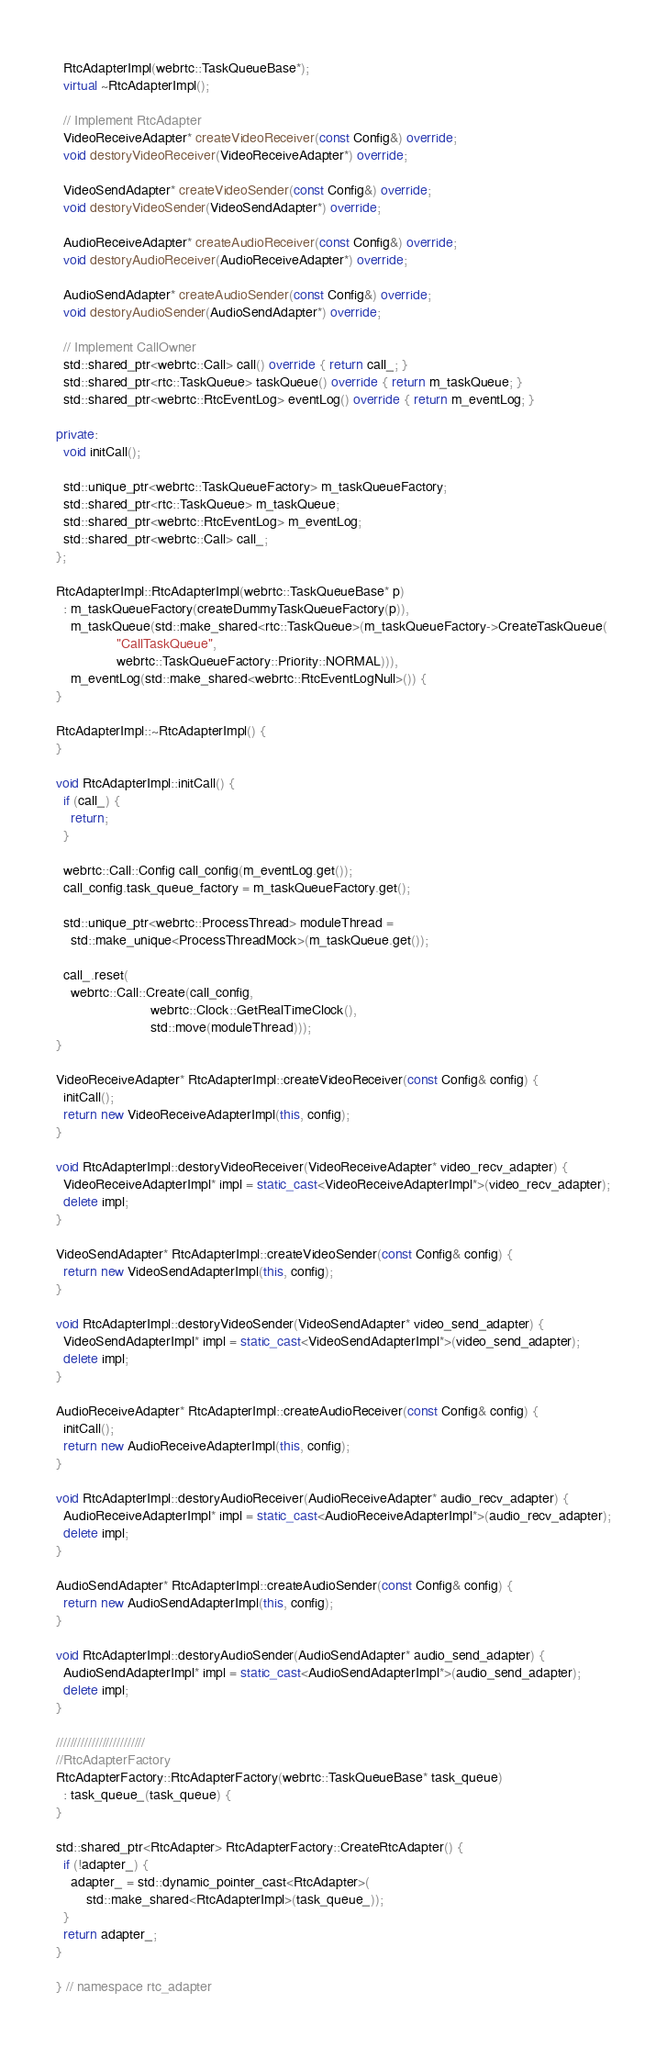Convert code to text. <code><loc_0><loc_0><loc_500><loc_500><_C++_>  RtcAdapterImpl(webrtc::TaskQueueBase*);
  virtual ~RtcAdapterImpl();

  // Implement RtcAdapter
  VideoReceiveAdapter* createVideoReceiver(const Config&) override;
  void destoryVideoReceiver(VideoReceiveAdapter*) override;
  
  VideoSendAdapter* createVideoSender(const Config&) override;
  void destoryVideoSender(VideoSendAdapter*) override;
  
  AudioReceiveAdapter* createAudioReceiver(const Config&) override;
  void destoryAudioReceiver(AudioReceiveAdapter*) override;
  
  AudioSendAdapter* createAudioSender(const Config&) override;
  void destoryAudioSender(AudioSendAdapter*) override;

  // Implement CallOwner
  std::shared_ptr<webrtc::Call> call() override { return call_; }
  std::shared_ptr<rtc::TaskQueue> taskQueue() override { return m_taskQueue; }
  std::shared_ptr<webrtc::RtcEventLog> eventLog() override { return m_eventLog; }

private:
  void initCall();

  std::unique_ptr<webrtc::TaskQueueFactory> m_taskQueueFactory;
  std::shared_ptr<rtc::TaskQueue> m_taskQueue;
  std::shared_ptr<webrtc::RtcEventLog> m_eventLog;
  std::shared_ptr<webrtc::Call> call_;
};

RtcAdapterImpl::RtcAdapterImpl(webrtc::TaskQueueBase* p)
  : m_taskQueueFactory(createDummyTaskQueueFactory(p)),
    m_taskQueue(std::make_shared<rtc::TaskQueue>(m_taskQueueFactory->CreateTaskQueue(
                "CallTaskQueue",
                webrtc::TaskQueueFactory::Priority::NORMAL))),
    m_eventLog(std::make_shared<webrtc::RtcEventLogNull>()) {
}

RtcAdapterImpl::~RtcAdapterImpl() {
}

void RtcAdapterImpl::initCall() {
  if (call_) {
    return;
  }
  
  webrtc::Call::Config call_config(m_eventLog.get());
  call_config.task_queue_factory = m_taskQueueFactory.get();

  std::unique_ptr<webrtc::ProcessThread> moduleThread =
    std::make_unique<ProcessThreadMock>(m_taskQueue.get());
    
  call_.reset(
    webrtc::Call::Create(call_config, 
                         webrtc::Clock::GetRealTimeClock(), 
                         std::move(moduleThread)));
}

VideoReceiveAdapter* RtcAdapterImpl::createVideoReceiver(const Config& config) {
  initCall();
  return new VideoReceiveAdapterImpl(this, config);
}

void RtcAdapterImpl::destoryVideoReceiver(VideoReceiveAdapter* video_recv_adapter) {
  VideoReceiveAdapterImpl* impl = static_cast<VideoReceiveAdapterImpl*>(video_recv_adapter);
  delete impl;
}

VideoSendAdapter* RtcAdapterImpl::createVideoSender(const Config& config) {
  return new VideoSendAdapterImpl(this, config);
}

void RtcAdapterImpl::destoryVideoSender(VideoSendAdapter* video_send_adapter) {
  VideoSendAdapterImpl* impl = static_cast<VideoSendAdapterImpl*>(video_send_adapter);
  delete impl;
}

AudioReceiveAdapter* RtcAdapterImpl::createAudioReceiver(const Config& config) {
  initCall();
  return new AudioReceiveAdapterImpl(this, config);
}

void RtcAdapterImpl::destoryAudioReceiver(AudioReceiveAdapter* audio_recv_adapter) {
  AudioReceiveAdapterImpl* impl = static_cast<AudioReceiveAdapterImpl*>(audio_recv_adapter);
  delete impl;
}

AudioSendAdapter* RtcAdapterImpl::createAudioSender(const Config& config) {
  return new AudioSendAdapterImpl(this, config);
}

void RtcAdapterImpl::destoryAudioSender(AudioSendAdapter* audio_send_adapter) {
  AudioSendAdapterImpl* impl = static_cast<AudioSendAdapterImpl*>(audio_send_adapter);
  delete impl;
}

/////////////////////////
//RtcAdapterFactory
RtcAdapterFactory::RtcAdapterFactory(webrtc::TaskQueueBase* task_queue) 
  : task_queue_(task_queue) {
}

std::shared_ptr<RtcAdapter> RtcAdapterFactory::CreateRtcAdapter() {
  if (!adapter_) {
    adapter_ = std::dynamic_pointer_cast<RtcAdapter>(
        std::make_shared<RtcAdapterImpl>(task_queue_));
  }
  return adapter_;
}

} // namespace rtc_adapter

</code> 